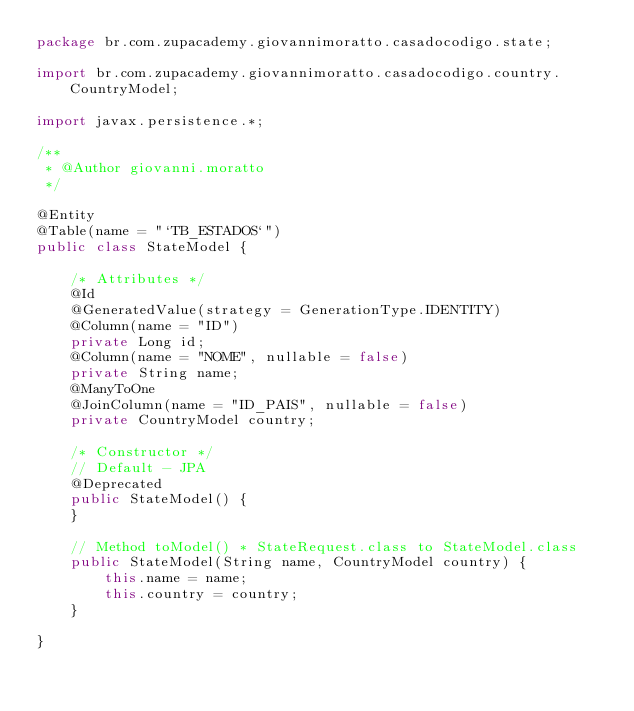<code> <loc_0><loc_0><loc_500><loc_500><_Java_>package br.com.zupacademy.giovannimoratto.casadocodigo.state;

import br.com.zupacademy.giovannimoratto.casadocodigo.country.CountryModel;

import javax.persistence.*;

/**
 * @Author giovanni.moratto
 */

@Entity
@Table(name = "`TB_ESTADOS`")
public class StateModel {

    /* Attributes */
    @Id
    @GeneratedValue(strategy = GenerationType.IDENTITY)
    @Column(name = "ID")
    private Long id;
    @Column(name = "NOME", nullable = false)
    private String name;
    @ManyToOne
    @JoinColumn(name = "ID_PAIS", nullable = false)
    private CountryModel country;

    /* Constructor */
    // Default - JPA
    @Deprecated
    public StateModel() {
    }

    // Method toModel() * StateRequest.class to StateModel.class
    public StateModel(String name, CountryModel country) {
        this.name = name;
        this.country = country;
    }

}</code> 